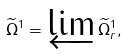Convert formula to latex. <formula><loc_0><loc_0><loc_500><loc_500>\widetilde { \Omega } ^ { 1 } = \varprojlim \widetilde { \Omega } _ { r } ^ { 1 } ,</formula> 